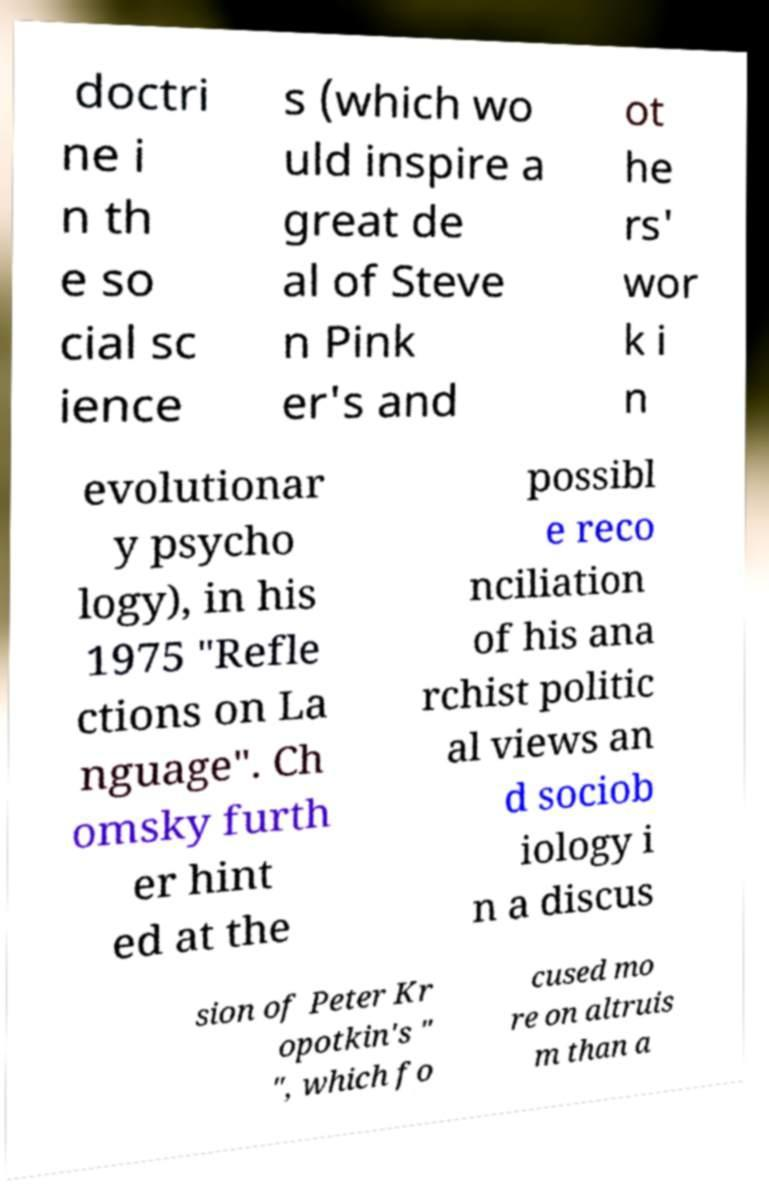Please identify and transcribe the text found in this image. doctri ne i n th e so cial sc ience s (which wo uld inspire a great de al of Steve n Pink er's and ot he rs' wor k i n evolutionar y psycho logy), in his 1975 "Refle ctions on La nguage". Ch omsky furth er hint ed at the possibl e reco nciliation of his ana rchist politic al views an d sociob iology i n a discus sion of Peter Kr opotkin's " ", which fo cused mo re on altruis m than a 